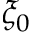<formula> <loc_0><loc_0><loc_500><loc_500>\xi _ { 0 }</formula> 